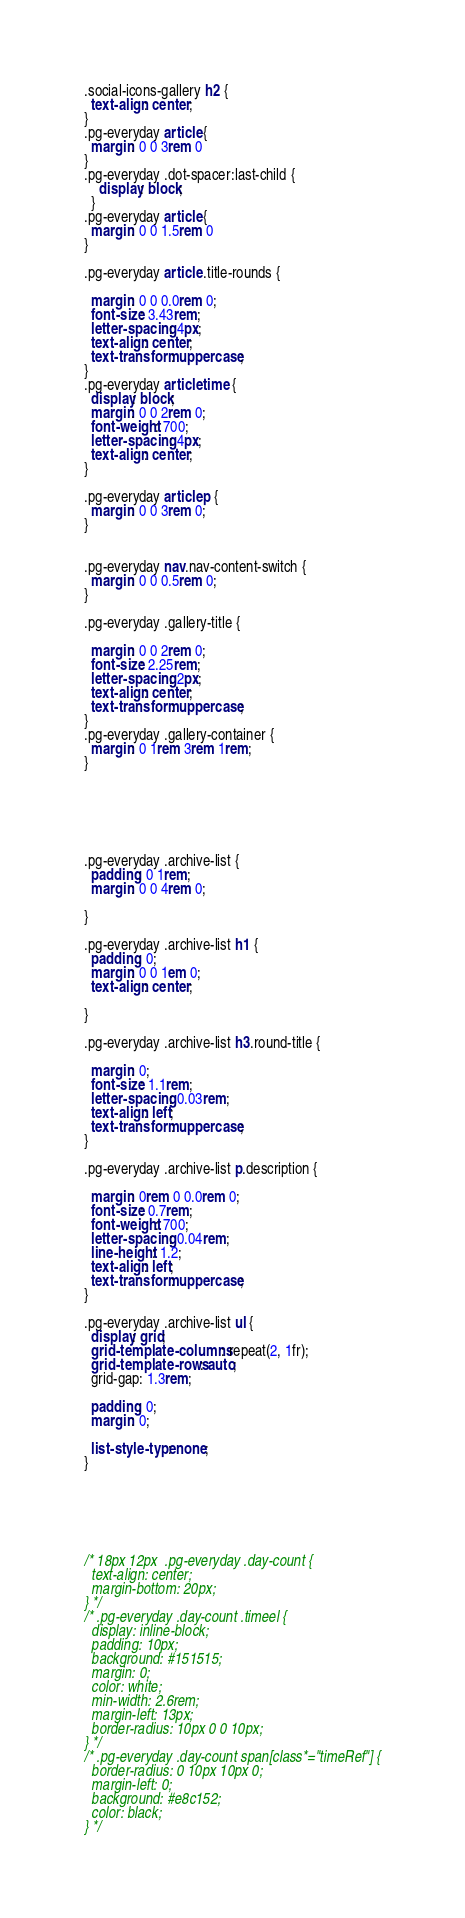Convert code to text. <code><loc_0><loc_0><loc_500><loc_500><_CSS_>.social-icons-gallery h2 {
  text-align: center;
}
.pg-everyday article {
  margin: 0 0 3rem 0
}
.pg-everyday .dot-spacer:last-child {
    display: block;
  }
.pg-everyday article {
  margin: 0 0 1.5rem 0
}

.pg-everyday article .title-rounds {

  margin: 0 0 0.0rem 0;
  font-size: 3.43rem;
  letter-spacing: 4px;
  text-align: center;
  text-transform: uppercase;
}
.pg-everyday article time {
  display: block;
  margin: 0 0 2rem 0;
  font-weight: 700;
  letter-spacing: 4px;
  text-align: center;
}

.pg-everyday article p {
  margin: 0 0 3rem 0;
}


.pg-everyday nav.nav-content-switch {
  margin: 0 0 0.5rem 0;
}

.pg-everyday .gallery-title {

  margin: 0 0 2rem 0;
  font-size: 2.25rem;
  letter-spacing: 2px;
  text-align: center;
  text-transform: uppercase;
}
.pg-everyday .gallery-container {
  margin: 0 1rem 3rem 1rem;
}






.pg-everyday .archive-list {
  padding: 0 1rem;
  margin: 0 0 4rem 0;

}

.pg-everyday .archive-list h1 {
  padding: 0;
  margin: 0 0 1em 0;
  text-align: center;

}

.pg-everyday .archive-list h3.round-title {

  margin: 0;
  font-size: 1.1rem;
  letter-spacing: 0.03rem;
  text-align: left;
  text-transform: uppercase;
}

.pg-everyday .archive-list p.description {

  margin: 0rem 0 0.0rem 0;
  font-size: 0.7rem;
  font-weight: 700;
  letter-spacing: 0.04rem;
  line-height: 1.2;
  text-align: left;
  text-transform: uppercase;
}

.pg-everyday .archive-list ul {
  display: grid;
  grid-template-columns: repeat(2, 1fr);
  grid-template-rows: auto;
  grid-gap: 1.3rem;

  padding: 0;
  margin: 0;

  list-style-type: none;
}






/* 18px 12px  .pg-everyday .day-count {
  text-align: center;
  margin-bottom: 20px;
} */
/* .pg-everyday .day-count .timeel {
  display: inline-block;
  padding: 10px;
  background: #151515;
  margin: 0;
  color: white;
  min-width: 2.6rem;
  margin-left: 13px;
  border-radius: 10px 0 0 10px;
} */
/* .pg-everyday .day-count span[class*="timeRef"] {
  border-radius: 0 10px 10px 0;
  margin-left: 0;
  background: #e8c152;
  color: black;
} */
</code> 